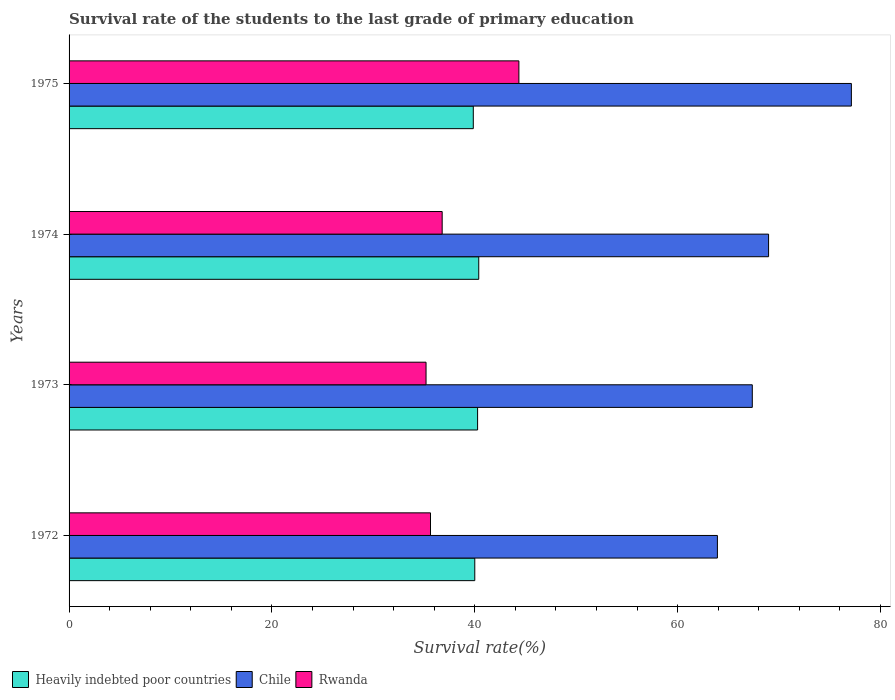Are the number of bars on each tick of the Y-axis equal?
Your answer should be compact. Yes. What is the label of the 3rd group of bars from the top?
Offer a very short reply. 1973. What is the survival rate of the students in Heavily indebted poor countries in 1974?
Give a very brief answer. 40.39. Across all years, what is the maximum survival rate of the students in Heavily indebted poor countries?
Provide a succinct answer. 40.39. Across all years, what is the minimum survival rate of the students in Heavily indebted poor countries?
Keep it short and to the point. 39.85. In which year was the survival rate of the students in Chile maximum?
Your answer should be very brief. 1975. In which year was the survival rate of the students in Chile minimum?
Keep it short and to the point. 1972. What is the total survival rate of the students in Rwanda in the graph?
Keep it short and to the point. 151.96. What is the difference between the survival rate of the students in Heavily indebted poor countries in 1972 and that in 1973?
Your response must be concise. -0.28. What is the difference between the survival rate of the students in Heavily indebted poor countries in 1975 and the survival rate of the students in Rwanda in 1972?
Offer a terse response. 4.22. What is the average survival rate of the students in Chile per year?
Give a very brief answer. 69.34. In the year 1974, what is the difference between the survival rate of the students in Heavily indebted poor countries and survival rate of the students in Chile?
Make the answer very short. -28.57. What is the ratio of the survival rate of the students in Chile in 1972 to that in 1975?
Provide a short and direct response. 0.83. Is the survival rate of the students in Chile in 1974 less than that in 1975?
Make the answer very short. Yes. Is the difference between the survival rate of the students in Heavily indebted poor countries in 1972 and 1974 greater than the difference between the survival rate of the students in Chile in 1972 and 1974?
Provide a succinct answer. Yes. What is the difference between the highest and the second highest survival rate of the students in Heavily indebted poor countries?
Give a very brief answer. 0.11. What is the difference between the highest and the lowest survival rate of the students in Chile?
Keep it short and to the point. 13.21. In how many years, is the survival rate of the students in Heavily indebted poor countries greater than the average survival rate of the students in Heavily indebted poor countries taken over all years?
Keep it short and to the point. 2. Is the sum of the survival rate of the students in Rwanda in 1972 and 1974 greater than the maximum survival rate of the students in Heavily indebted poor countries across all years?
Offer a terse response. Yes. What does the 1st bar from the bottom in 1973 represents?
Give a very brief answer. Heavily indebted poor countries. What is the difference between two consecutive major ticks on the X-axis?
Offer a very short reply. 20. Does the graph contain any zero values?
Your answer should be very brief. No. Where does the legend appear in the graph?
Your answer should be compact. Bottom left. How are the legend labels stacked?
Offer a terse response. Horizontal. What is the title of the graph?
Offer a terse response. Survival rate of the students to the last grade of primary education. What is the label or title of the X-axis?
Ensure brevity in your answer.  Survival rate(%). What is the label or title of the Y-axis?
Give a very brief answer. Years. What is the Survival rate(%) of Heavily indebted poor countries in 1972?
Your answer should be very brief. 40. What is the Survival rate(%) in Chile in 1972?
Give a very brief answer. 63.92. What is the Survival rate(%) of Rwanda in 1972?
Make the answer very short. 35.63. What is the Survival rate(%) in Heavily indebted poor countries in 1973?
Offer a very short reply. 40.28. What is the Survival rate(%) in Chile in 1973?
Ensure brevity in your answer.  67.36. What is the Survival rate(%) of Rwanda in 1973?
Keep it short and to the point. 35.19. What is the Survival rate(%) in Heavily indebted poor countries in 1974?
Your response must be concise. 40.39. What is the Survival rate(%) in Chile in 1974?
Keep it short and to the point. 68.96. What is the Survival rate(%) of Rwanda in 1974?
Offer a terse response. 36.78. What is the Survival rate(%) of Heavily indebted poor countries in 1975?
Give a very brief answer. 39.85. What is the Survival rate(%) in Chile in 1975?
Offer a very short reply. 77.13. What is the Survival rate(%) of Rwanda in 1975?
Give a very brief answer. 44.35. Across all years, what is the maximum Survival rate(%) in Heavily indebted poor countries?
Your answer should be compact. 40.39. Across all years, what is the maximum Survival rate(%) of Chile?
Your answer should be compact. 77.13. Across all years, what is the maximum Survival rate(%) in Rwanda?
Give a very brief answer. 44.35. Across all years, what is the minimum Survival rate(%) in Heavily indebted poor countries?
Your response must be concise. 39.85. Across all years, what is the minimum Survival rate(%) in Chile?
Your answer should be compact. 63.92. Across all years, what is the minimum Survival rate(%) of Rwanda?
Your answer should be very brief. 35.19. What is the total Survival rate(%) in Heavily indebted poor countries in the graph?
Your response must be concise. 160.52. What is the total Survival rate(%) of Chile in the graph?
Provide a short and direct response. 277.37. What is the total Survival rate(%) of Rwanda in the graph?
Offer a very short reply. 151.96. What is the difference between the Survival rate(%) of Heavily indebted poor countries in 1972 and that in 1973?
Offer a terse response. -0.28. What is the difference between the Survival rate(%) of Chile in 1972 and that in 1973?
Offer a very short reply. -3.44. What is the difference between the Survival rate(%) of Rwanda in 1972 and that in 1973?
Offer a very short reply. 0.44. What is the difference between the Survival rate(%) in Heavily indebted poor countries in 1972 and that in 1974?
Ensure brevity in your answer.  -0.39. What is the difference between the Survival rate(%) of Chile in 1972 and that in 1974?
Provide a succinct answer. -5.04. What is the difference between the Survival rate(%) of Rwanda in 1972 and that in 1974?
Offer a terse response. -1.15. What is the difference between the Survival rate(%) of Heavily indebted poor countries in 1972 and that in 1975?
Offer a very short reply. 0.15. What is the difference between the Survival rate(%) in Chile in 1972 and that in 1975?
Offer a terse response. -13.21. What is the difference between the Survival rate(%) of Rwanda in 1972 and that in 1975?
Provide a succinct answer. -8.71. What is the difference between the Survival rate(%) of Heavily indebted poor countries in 1973 and that in 1974?
Your response must be concise. -0.11. What is the difference between the Survival rate(%) in Chile in 1973 and that in 1974?
Offer a very short reply. -1.6. What is the difference between the Survival rate(%) in Rwanda in 1973 and that in 1974?
Offer a very short reply. -1.59. What is the difference between the Survival rate(%) of Heavily indebted poor countries in 1973 and that in 1975?
Your answer should be compact. 0.42. What is the difference between the Survival rate(%) in Chile in 1973 and that in 1975?
Offer a terse response. -9.77. What is the difference between the Survival rate(%) in Rwanda in 1973 and that in 1975?
Your answer should be very brief. -9.15. What is the difference between the Survival rate(%) in Heavily indebted poor countries in 1974 and that in 1975?
Make the answer very short. 0.54. What is the difference between the Survival rate(%) in Chile in 1974 and that in 1975?
Give a very brief answer. -8.16. What is the difference between the Survival rate(%) of Rwanda in 1974 and that in 1975?
Keep it short and to the point. -7.56. What is the difference between the Survival rate(%) in Heavily indebted poor countries in 1972 and the Survival rate(%) in Chile in 1973?
Your answer should be very brief. -27.36. What is the difference between the Survival rate(%) in Heavily indebted poor countries in 1972 and the Survival rate(%) in Rwanda in 1973?
Your response must be concise. 4.8. What is the difference between the Survival rate(%) in Chile in 1972 and the Survival rate(%) in Rwanda in 1973?
Provide a succinct answer. 28.73. What is the difference between the Survival rate(%) in Heavily indebted poor countries in 1972 and the Survival rate(%) in Chile in 1974?
Provide a succinct answer. -28.97. What is the difference between the Survival rate(%) in Heavily indebted poor countries in 1972 and the Survival rate(%) in Rwanda in 1974?
Ensure brevity in your answer.  3.21. What is the difference between the Survival rate(%) of Chile in 1972 and the Survival rate(%) of Rwanda in 1974?
Provide a short and direct response. 27.13. What is the difference between the Survival rate(%) in Heavily indebted poor countries in 1972 and the Survival rate(%) in Chile in 1975?
Your answer should be compact. -37.13. What is the difference between the Survival rate(%) in Heavily indebted poor countries in 1972 and the Survival rate(%) in Rwanda in 1975?
Your response must be concise. -4.35. What is the difference between the Survival rate(%) in Chile in 1972 and the Survival rate(%) in Rwanda in 1975?
Offer a very short reply. 19.57. What is the difference between the Survival rate(%) in Heavily indebted poor countries in 1973 and the Survival rate(%) in Chile in 1974?
Provide a short and direct response. -28.69. What is the difference between the Survival rate(%) in Heavily indebted poor countries in 1973 and the Survival rate(%) in Rwanda in 1974?
Provide a succinct answer. 3.49. What is the difference between the Survival rate(%) of Chile in 1973 and the Survival rate(%) of Rwanda in 1974?
Keep it short and to the point. 30.57. What is the difference between the Survival rate(%) in Heavily indebted poor countries in 1973 and the Survival rate(%) in Chile in 1975?
Offer a terse response. -36.85. What is the difference between the Survival rate(%) of Heavily indebted poor countries in 1973 and the Survival rate(%) of Rwanda in 1975?
Offer a terse response. -4.07. What is the difference between the Survival rate(%) of Chile in 1973 and the Survival rate(%) of Rwanda in 1975?
Give a very brief answer. 23.01. What is the difference between the Survival rate(%) of Heavily indebted poor countries in 1974 and the Survival rate(%) of Chile in 1975?
Make the answer very short. -36.74. What is the difference between the Survival rate(%) of Heavily indebted poor countries in 1974 and the Survival rate(%) of Rwanda in 1975?
Give a very brief answer. -3.96. What is the difference between the Survival rate(%) in Chile in 1974 and the Survival rate(%) in Rwanda in 1975?
Your answer should be compact. 24.62. What is the average Survival rate(%) of Heavily indebted poor countries per year?
Offer a terse response. 40.13. What is the average Survival rate(%) in Chile per year?
Your response must be concise. 69.34. What is the average Survival rate(%) of Rwanda per year?
Offer a terse response. 37.99. In the year 1972, what is the difference between the Survival rate(%) of Heavily indebted poor countries and Survival rate(%) of Chile?
Make the answer very short. -23.92. In the year 1972, what is the difference between the Survival rate(%) in Heavily indebted poor countries and Survival rate(%) in Rwanda?
Your response must be concise. 4.36. In the year 1972, what is the difference between the Survival rate(%) of Chile and Survival rate(%) of Rwanda?
Provide a short and direct response. 28.29. In the year 1973, what is the difference between the Survival rate(%) of Heavily indebted poor countries and Survival rate(%) of Chile?
Your answer should be compact. -27.08. In the year 1973, what is the difference between the Survival rate(%) in Heavily indebted poor countries and Survival rate(%) in Rwanda?
Provide a succinct answer. 5.08. In the year 1973, what is the difference between the Survival rate(%) of Chile and Survival rate(%) of Rwanda?
Ensure brevity in your answer.  32.16. In the year 1974, what is the difference between the Survival rate(%) of Heavily indebted poor countries and Survival rate(%) of Chile?
Your answer should be very brief. -28.57. In the year 1974, what is the difference between the Survival rate(%) of Heavily indebted poor countries and Survival rate(%) of Rwanda?
Your answer should be compact. 3.61. In the year 1974, what is the difference between the Survival rate(%) of Chile and Survival rate(%) of Rwanda?
Keep it short and to the point. 32.18. In the year 1975, what is the difference between the Survival rate(%) of Heavily indebted poor countries and Survival rate(%) of Chile?
Provide a short and direct response. -37.27. In the year 1975, what is the difference between the Survival rate(%) in Heavily indebted poor countries and Survival rate(%) in Rwanda?
Keep it short and to the point. -4.49. In the year 1975, what is the difference between the Survival rate(%) of Chile and Survival rate(%) of Rwanda?
Your answer should be compact. 32.78. What is the ratio of the Survival rate(%) in Heavily indebted poor countries in 1972 to that in 1973?
Provide a succinct answer. 0.99. What is the ratio of the Survival rate(%) in Chile in 1972 to that in 1973?
Offer a very short reply. 0.95. What is the ratio of the Survival rate(%) in Rwanda in 1972 to that in 1973?
Give a very brief answer. 1.01. What is the ratio of the Survival rate(%) in Heavily indebted poor countries in 1972 to that in 1974?
Your answer should be very brief. 0.99. What is the ratio of the Survival rate(%) of Chile in 1972 to that in 1974?
Your answer should be compact. 0.93. What is the ratio of the Survival rate(%) in Rwanda in 1972 to that in 1974?
Make the answer very short. 0.97. What is the ratio of the Survival rate(%) of Chile in 1972 to that in 1975?
Your answer should be very brief. 0.83. What is the ratio of the Survival rate(%) in Rwanda in 1972 to that in 1975?
Your response must be concise. 0.8. What is the ratio of the Survival rate(%) in Chile in 1973 to that in 1974?
Make the answer very short. 0.98. What is the ratio of the Survival rate(%) of Rwanda in 1973 to that in 1974?
Make the answer very short. 0.96. What is the ratio of the Survival rate(%) in Heavily indebted poor countries in 1973 to that in 1975?
Provide a short and direct response. 1.01. What is the ratio of the Survival rate(%) of Chile in 1973 to that in 1975?
Offer a very short reply. 0.87. What is the ratio of the Survival rate(%) of Rwanda in 1973 to that in 1975?
Your answer should be compact. 0.79. What is the ratio of the Survival rate(%) in Heavily indebted poor countries in 1974 to that in 1975?
Ensure brevity in your answer.  1.01. What is the ratio of the Survival rate(%) in Chile in 1974 to that in 1975?
Your answer should be compact. 0.89. What is the ratio of the Survival rate(%) in Rwanda in 1974 to that in 1975?
Your response must be concise. 0.83. What is the difference between the highest and the second highest Survival rate(%) of Heavily indebted poor countries?
Give a very brief answer. 0.11. What is the difference between the highest and the second highest Survival rate(%) in Chile?
Keep it short and to the point. 8.16. What is the difference between the highest and the second highest Survival rate(%) of Rwanda?
Provide a succinct answer. 7.56. What is the difference between the highest and the lowest Survival rate(%) in Heavily indebted poor countries?
Provide a short and direct response. 0.54. What is the difference between the highest and the lowest Survival rate(%) of Chile?
Keep it short and to the point. 13.21. What is the difference between the highest and the lowest Survival rate(%) in Rwanda?
Keep it short and to the point. 9.15. 